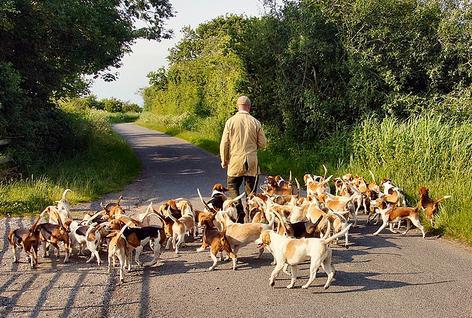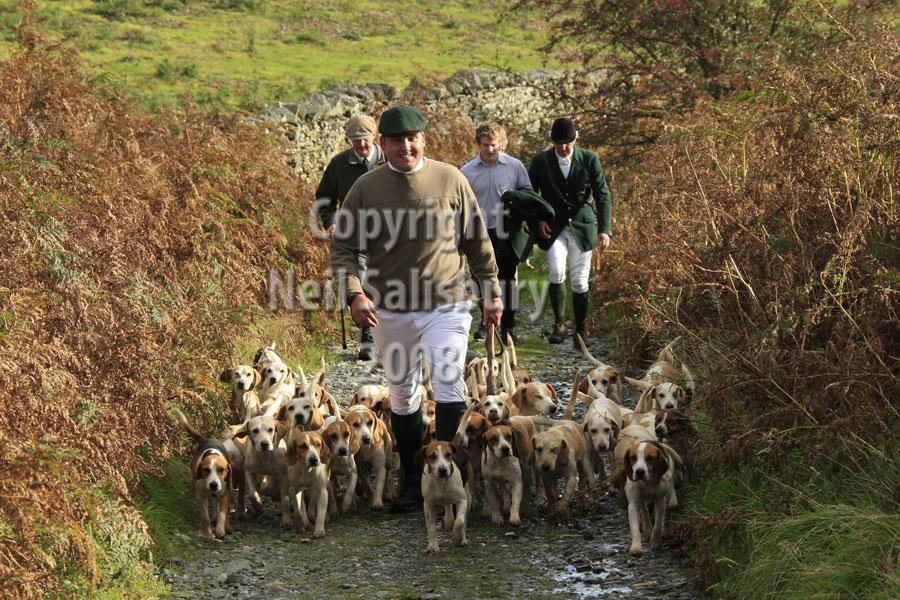The first image is the image on the left, the second image is the image on the right. Evaluate the accuracy of this statement regarding the images: "A man in green jacket, equestrian cap and white pants is astride a horse in the foreground of one image.". Is it true? Answer yes or no. No. The first image is the image on the left, the second image is the image on the right. For the images shown, is this caption "At least four riders are on horses near the dogs." true? Answer yes or no. No. 